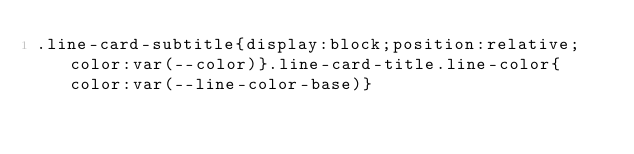Convert code to text. <code><loc_0><loc_0><loc_500><loc_500><_CSS_>.line-card-subtitle{display:block;position:relative;color:var(--color)}.line-card-title.line-color{color:var(--line-color-base)}</code> 